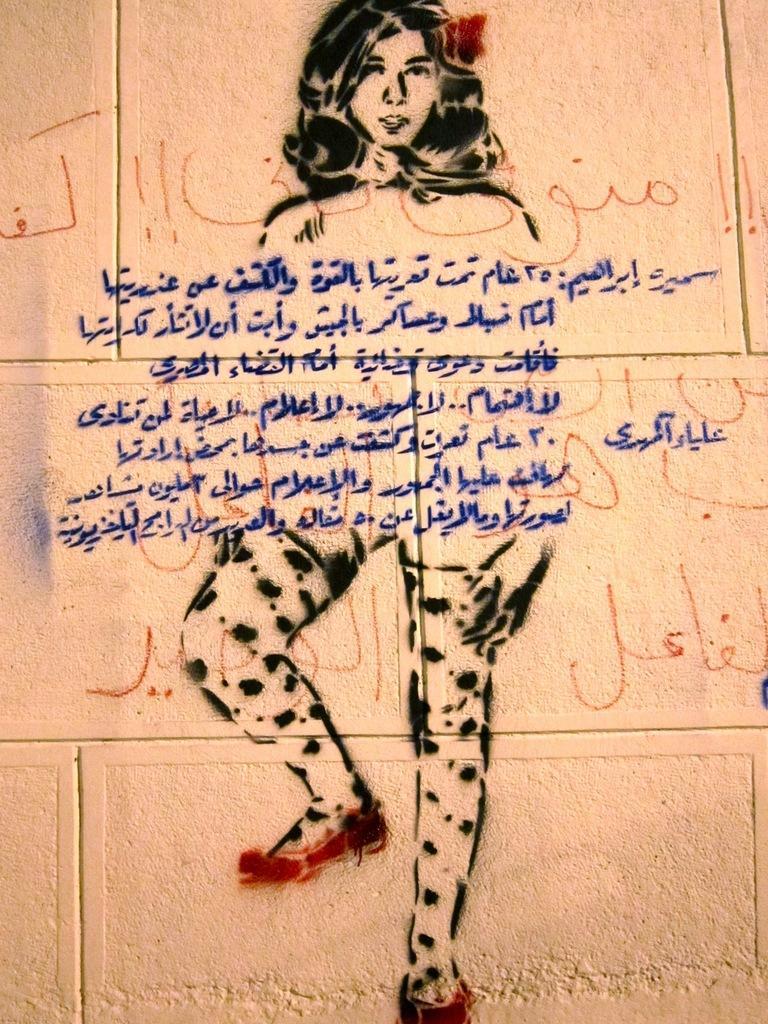Please provide a concise description of this image. We can see painting of woman and something written on a wall. 